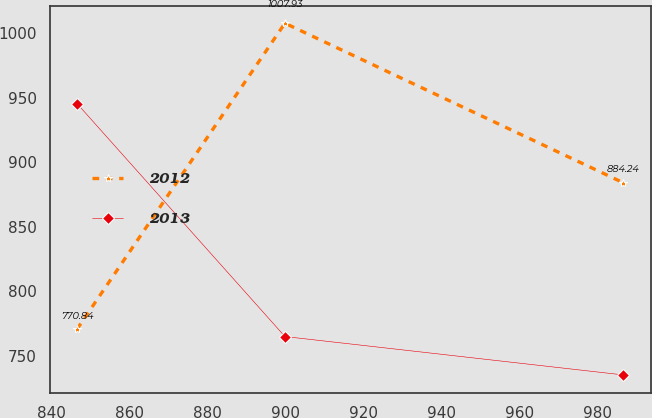<chart> <loc_0><loc_0><loc_500><loc_500><line_chart><ecel><fcel>2012<fcel>2013<nl><fcel>846.44<fcel>770.84<fcel>945.69<nl><fcel>899.76<fcel>1007.93<fcel>765.09<nl><fcel>986.58<fcel>884.24<fcel>735.33<nl></chart> 